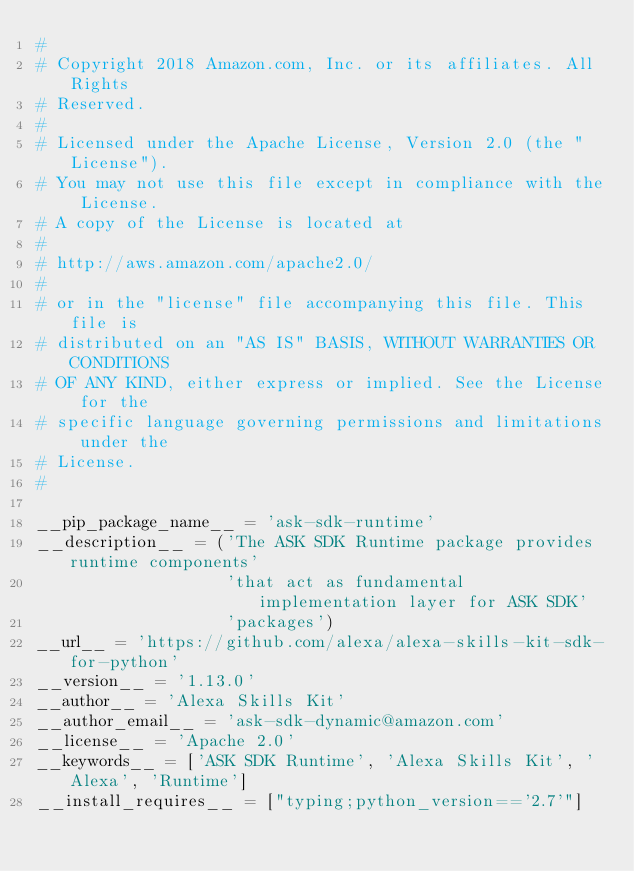<code> <loc_0><loc_0><loc_500><loc_500><_Python_>#
# Copyright 2018 Amazon.com, Inc. or its affiliates. All Rights
# Reserved.
#
# Licensed under the Apache License, Version 2.0 (the "License").
# You may not use this file except in compliance with the License.
# A copy of the License is located at
#
# http://aws.amazon.com/apache2.0/
#
# or in the "license" file accompanying this file. This file is
# distributed on an "AS IS" BASIS, WITHOUT WARRANTIES OR CONDITIONS
# OF ANY KIND, either express or implied. See the License for the
# specific language governing permissions and limitations under the
# License.
#

__pip_package_name__ = 'ask-sdk-runtime'
__description__ = ('The ASK SDK Runtime package provides runtime components'
                   'that act as fundamental implementation layer for ASK SDK'
                   'packages')
__url__ = 'https://github.com/alexa/alexa-skills-kit-sdk-for-python'
__version__ = '1.13.0'
__author__ = 'Alexa Skills Kit'
__author_email__ = 'ask-sdk-dynamic@amazon.com'
__license__ = 'Apache 2.0'
__keywords__ = ['ASK SDK Runtime', 'Alexa Skills Kit', 'Alexa', 'Runtime']
__install_requires__ = ["typing;python_version=='2.7'"]

</code> 